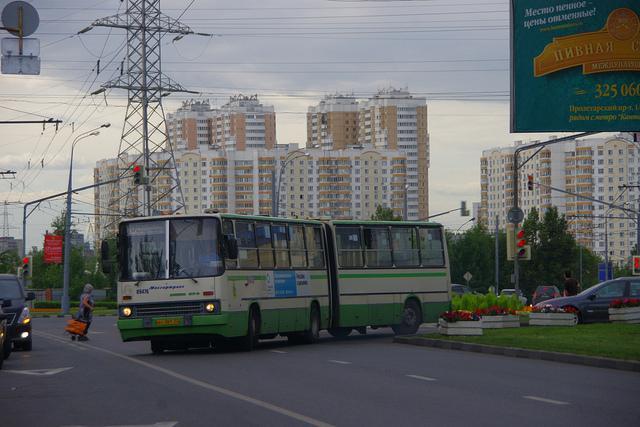How many cars does the train Offer?
Give a very brief answer. 2. How many levels does the bus have?
Give a very brief answer. 1. How many buses on the road?
Give a very brief answer. 1. 